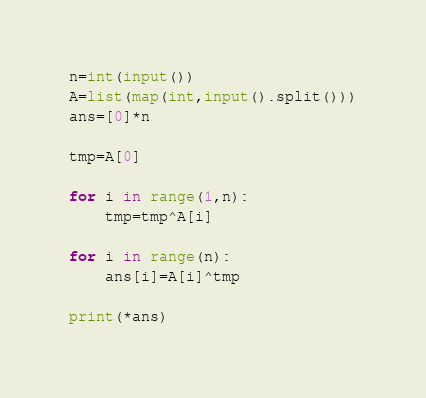<code> <loc_0><loc_0><loc_500><loc_500><_Python_>n=int(input())
A=list(map(int,input().split()))
ans=[0]*n

tmp=A[0]

for i in range(1,n):
    tmp=tmp^A[i]

for i in range(n):
    ans[i]=A[i]^tmp
    
print(*ans)</code> 